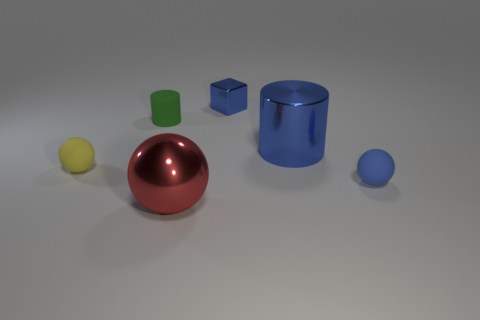What materials do the objects in the image appear to be made of? The objects seem to be made of different materials. The spherical object has a reflective metallic finish, suggesting it could be metal. The cube and the cylinder appear to have a matte finish, which might indicate a plastic or painted metal surface. The small sphere has a smoother surface that could be plastic or glass based on the reflection and refraction qualities. 